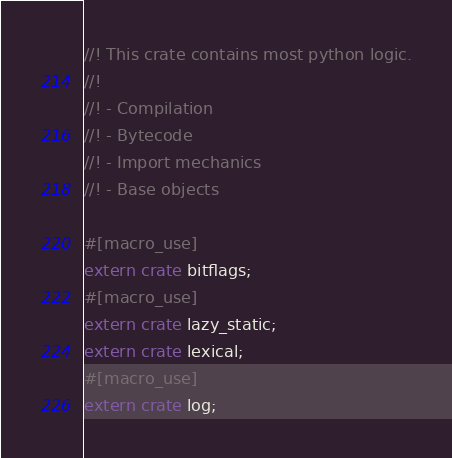Convert code to text. <code><loc_0><loc_0><loc_500><loc_500><_Rust_>//! This crate contains most python logic.
//!
//! - Compilation
//! - Bytecode
//! - Import mechanics
//! - Base objects

#[macro_use]
extern crate bitflags;
#[macro_use]
extern crate lazy_static;
extern crate lexical;
#[macro_use]
extern crate log;</code> 